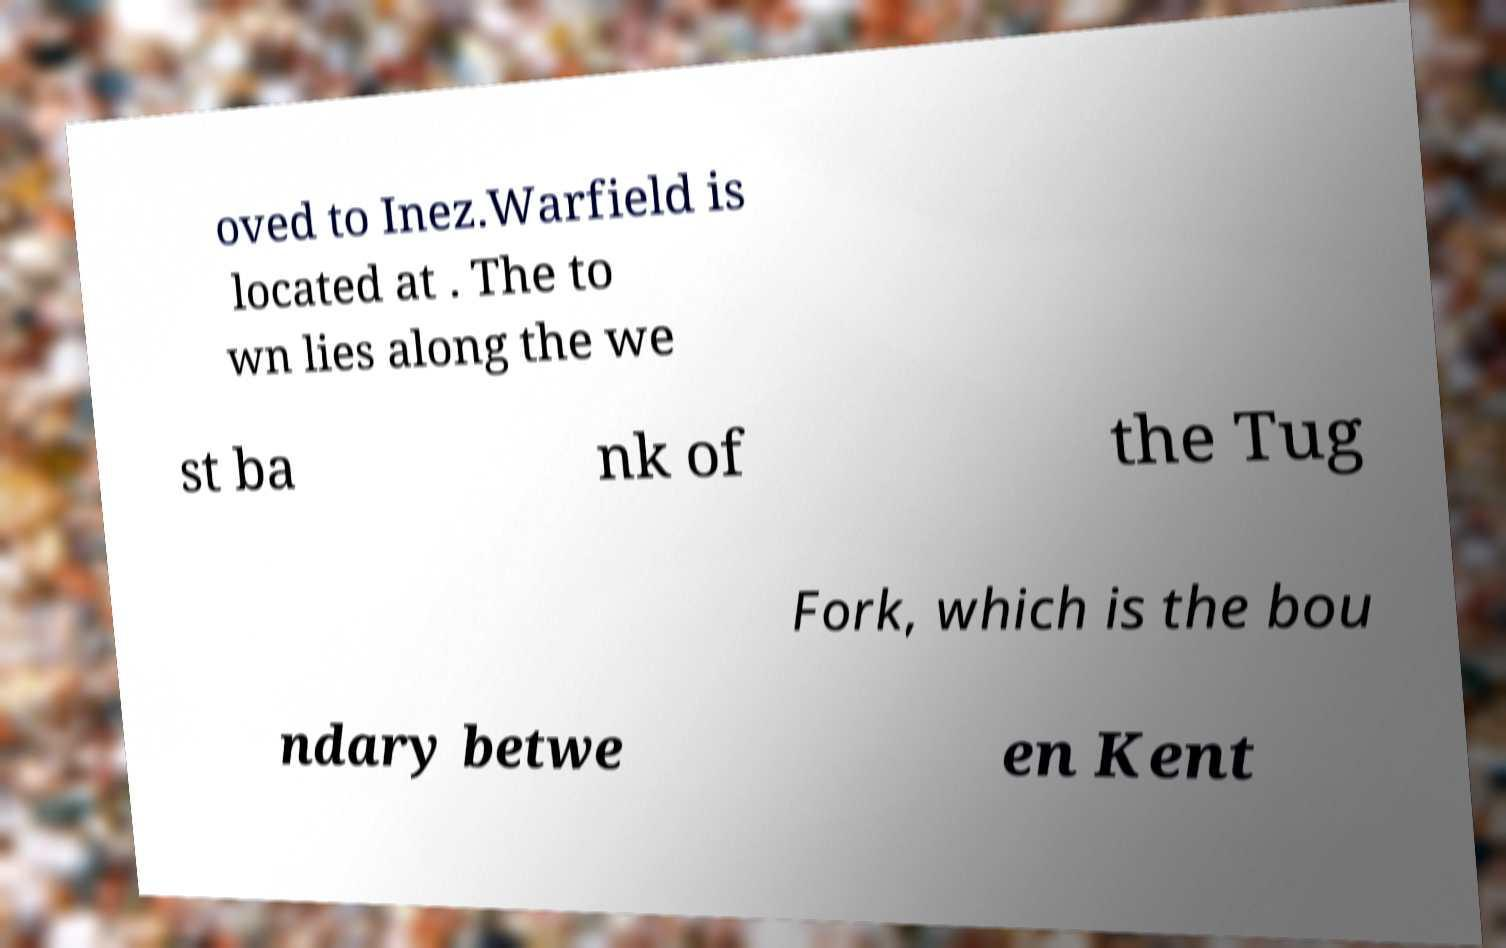Can you read and provide the text displayed in the image?This photo seems to have some interesting text. Can you extract and type it out for me? oved to Inez.Warfield is located at . The to wn lies along the we st ba nk of the Tug Fork, which is the bou ndary betwe en Kent 